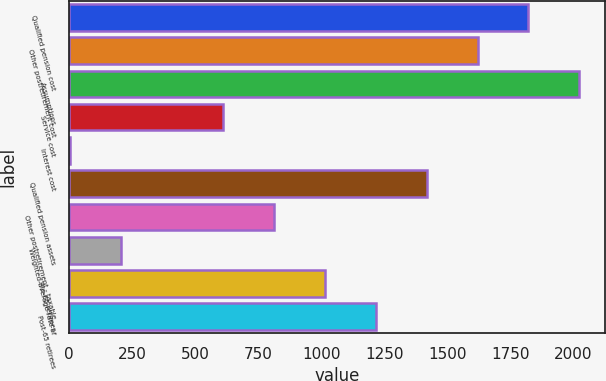Convert chart to OTSL. <chart><loc_0><loc_0><loc_500><loc_500><bar_chart><fcel>Qualified pension cost<fcel>Other postretirement cost<fcel>Assumptions<fcel>Service cost<fcel>Interest cost<fcel>Qualified pension assets<fcel>Other postretirement - taxable<fcel>Weighted-average rate of<fcel>Pre-65 retirees<fcel>Post-65 retirees<nl><fcel>1821.99<fcel>1619.98<fcel>2024<fcel>609.93<fcel>3.9<fcel>1417.97<fcel>811.94<fcel>205.91<fcel>1013.95<fcel>1215.96<nl></chart> 